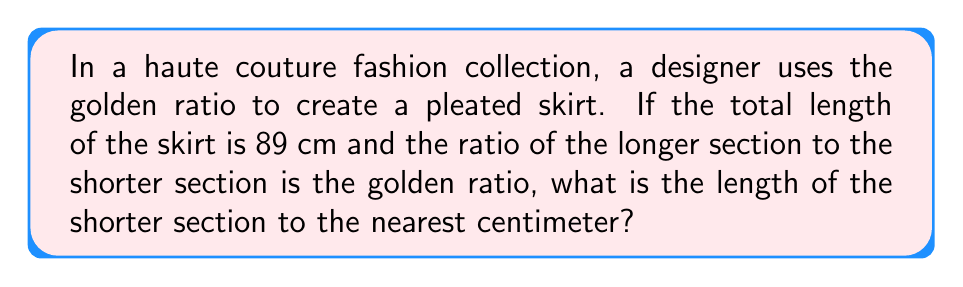Give your solution to this math problem. Let's approach this step-by-step:

1) The golden ratio, denoted by $\phi$, is approximately equal to 1.618034...

2) Let $x$ be the length of the shorter section and $y$ be the length of the longer section.

3) We know that $x + y = 89$ cm (total length of the skirt)

4) The golden ratio states that $\frac{y}{x} = \phi$

5) We can express $y$ in terms of $x$:
   $y = \phi x$

6) Substituting this into our first equation:
   $x + \phi x = 89$
   $x(1 + \phi) = 89$

7) We know that $1 + \phi = \phi^2$ (a property of the golden ratio)

8) So our equation becomes:
   $x\phi^2 = 89$

9) Solving for $x$:
   $x = \frac{89}{\phi^2}$

10) $\phi^2 \approx 2.618034$

11) Therefore:
    $x \approx \frac{89}{2.618034} \approx 33.9948$ cm

12) Rounding to the nearest centimeter:
    $x \approx 34$ cm
Answer: 34 cm 